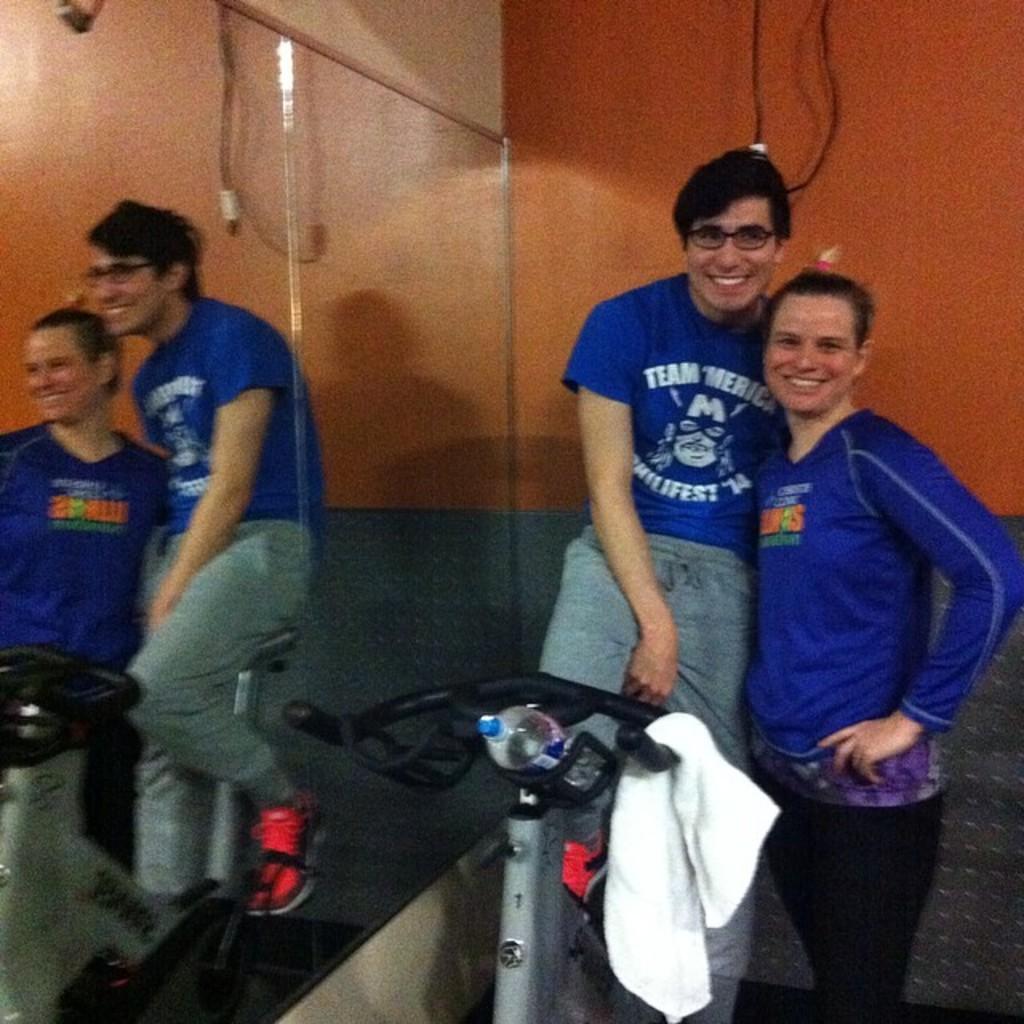In one or two sentences, can you explain what this image depicts? In this image, there is a person wearing clothes and sitting on exercise bike beside the mirror. There is an another person on the right side of the image standing and wearing clothes. 